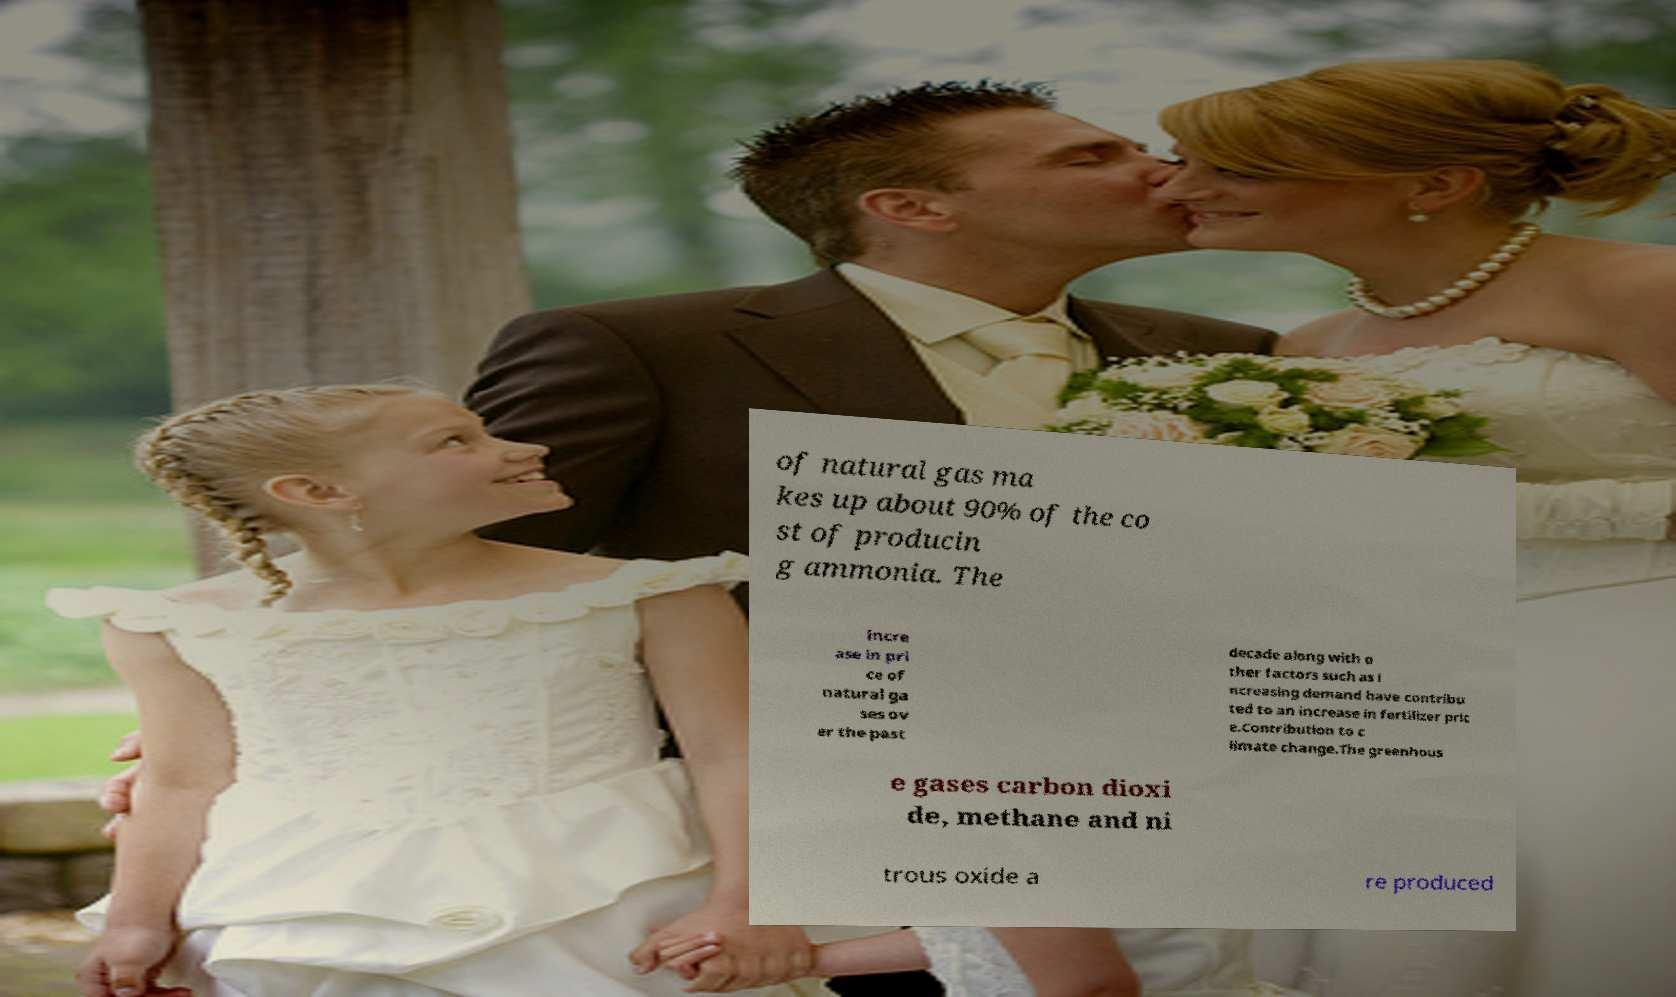Could you assist in decoding the text presented in this image and type it out clearly? of natural gas ma kes up about 90% of the co st of producin g ammonia. The incre ase in pri ce of natural ga ses ov er the past decade along with o ther factors such as i ncreasing demand have contribu ted to an increase in fertilizer pric e.Contribution to c limate change.The greenhous e gases carbon dioxi de, methane and ni trous oxide a re produced 